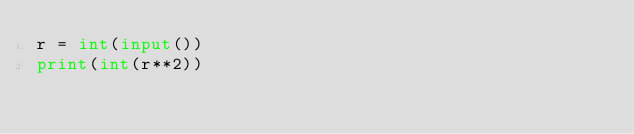Convert code to text. <code><loc_0><loc_0><loc_500><loc_500><_Python_>r = int(input())
print(int(r**2))
</code> 